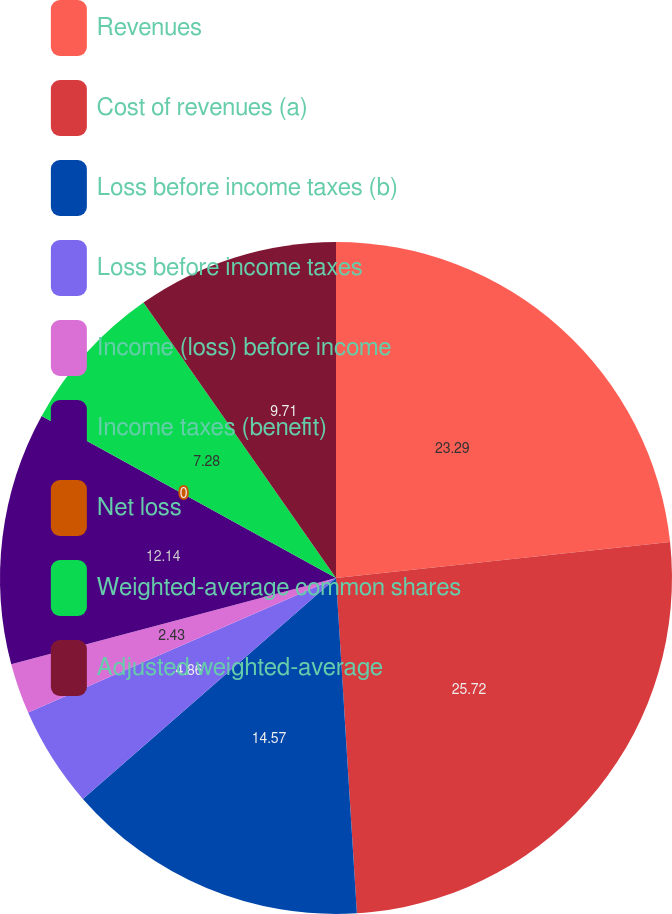Convert chart. <chart><loc_0><loc_0><loc_500><loc_500><pie_chart><fcel>Revenues<fcel>Cost of revenues (a)<fcel>Loss before income taxes (b)<fcel>Loss before income taxes<fcel>Income (loss) before income<fcel>Income taxes (benefit)<fcel>Net loss<fcel>Weighted-average common shares<fcel>Adjusted weighted-average<nl><fcel>23.29%<fcel>25.72%<fcel>14.57%<fcel>4.86%<fcel>2.43%<fcel>12.14%<fcel>0.0%<fcel>7.28%<fcel>9.71%<nl></chart> 